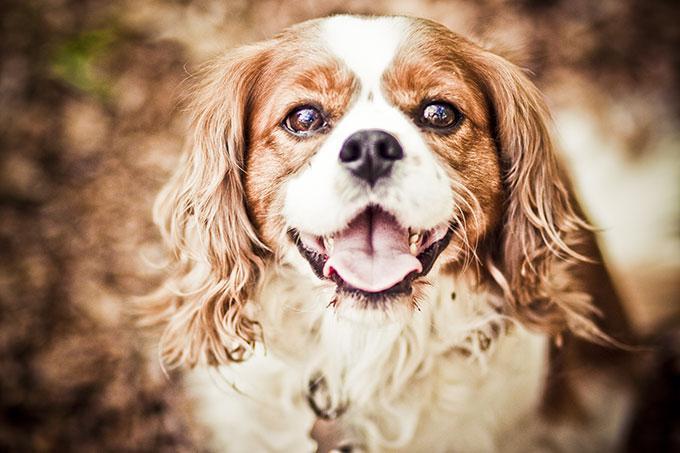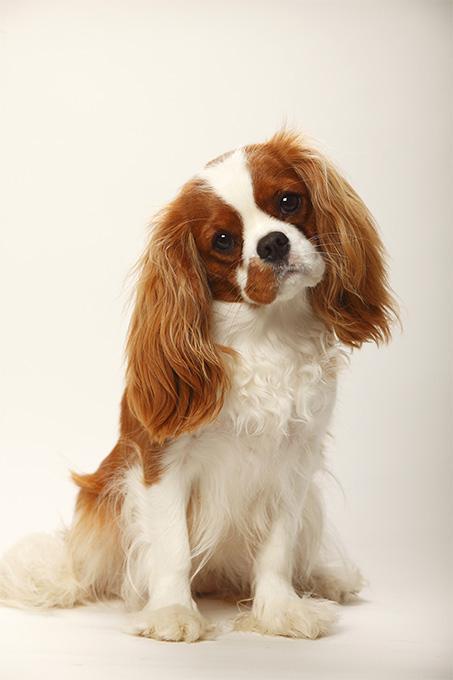The first image is the image on the left, the second image is the image on the right. Assess this claim about the two images: "At least one image shows a dog with a dog tag.". Correct or not? Answer yes or no. Yes. The first image is the image on the left, the second image is the image on the right. Examine the images to the left and right. Is the description "The lone dog within the left image is not smiling." accurate? Answer yes or no. No. 